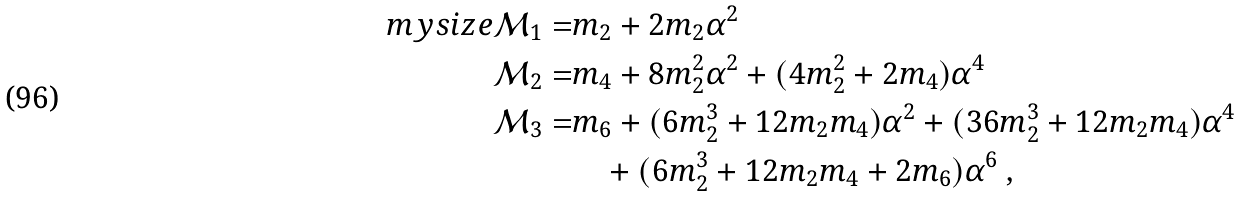Convert formula to latex. <formula><loc_0><loc_0><loc_500><loc_500>\ m y s i z e \mathcal { M } _ { 1 } = & m _ { 2 } + 2 m _ { 2 } \alpha ^ { 2 } \\ \mathcal { M } _ { 2 } = & m _ { 4 } + 8 m _ { 2 } ^ { 2 } \alpha ^ { 2 } + ( 4 m _ { 2 } ^ { 2 } + 2 m _ { 4 } ) \alpha ^ { 4 } \\ \mathcal { M } _ { 3 } = & m _ { 6 } + ( 6 m _ { 2 } ^ { 3 } + 1 2 m _ { 2 } m _ { 4 } ) \alpha ^ { 2 } + ( 3 6 m _ { 2 } ^ { 3 } + 1 2 m _ { 2 } m _ { 4 } ) \alpha ^ { 4 } \\ & \quad + ( 6 m _ { 2 } ^ { 3 } + 1 2 m _ { 2 } m _ { 4 } + 2 m _ { 6 } ) \alpha ^ { 6 } \ ,</formula> 